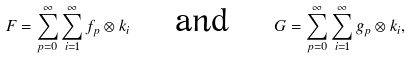Convert formula to latex. <formula><loc_0><loc_0><loc_500><loc_500>F = \sum _ { p = 0 } ^ { \infty } \sum _ { i = 1 } ^ { \infty } f _ { p } \otimes k _ { i } \quad \text { and } \quad G = \sum _ { p = 0 } ^ { \infty } \sum _ { i = 1 } ^ { \infty } g _ { p } \otimes k _ { i } ,</formula> 